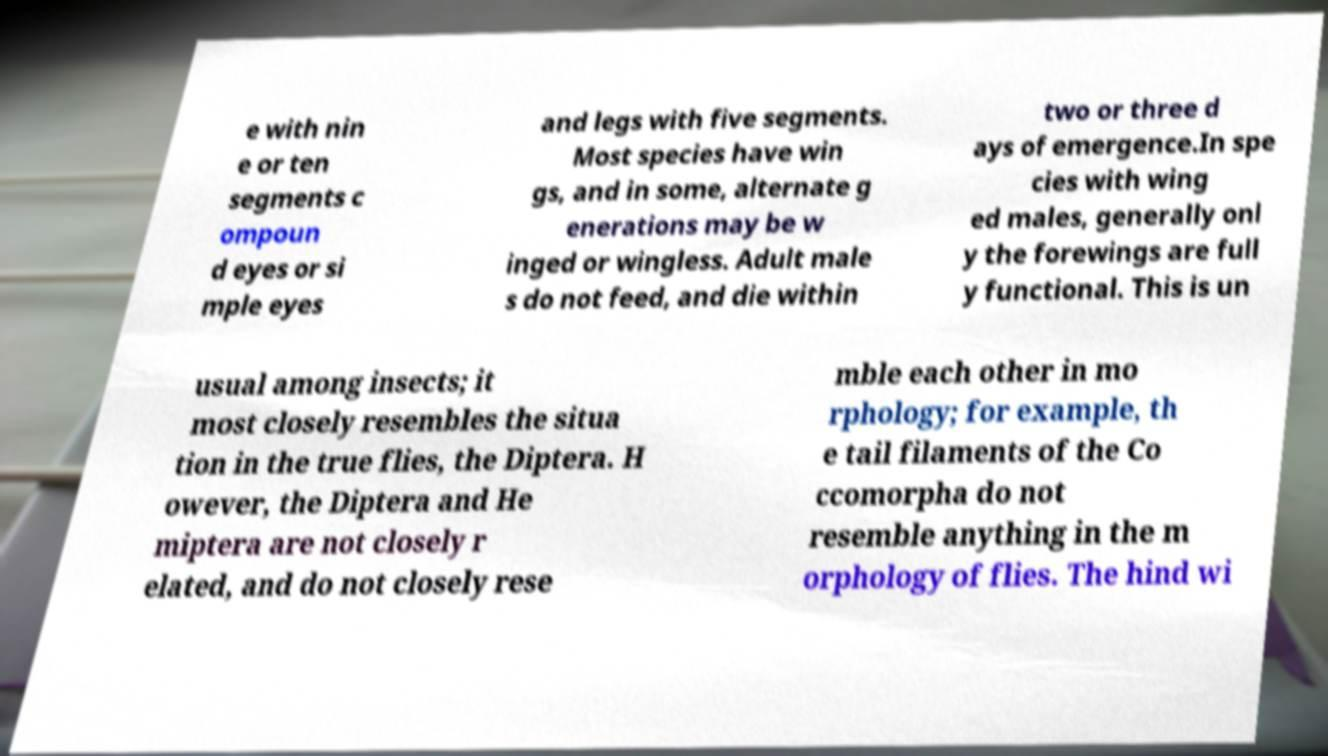I need the written content from this picture converted into text. Can you do that? e with nin e or ten segments c ompoun d eyes or si mple eyes and legs with five segments. Most species have win gs, and in some, alternate g enerations may be w inged or wingless. Adult male s do not feed, and die within two or three d ays of emergence.In spe cies with wing ed males, generally onl y the forewings are full y functional. This is un usual among insects; it most closely resembles the situa tion in the true flies, the Diptera. H owever, the Diptera and He miptera are not closely r elated, and do not closely rese mble each other in mo rphology; for example, th e tail filaments of the Co ccomorpha do not resemble anything in the m orphology of flies. The hind wi 